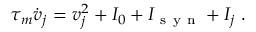Convert formula to latex. <formula><loc_0><loc_0><loc_500><loc_500>\tau _ { m } \dot { v } _ { j } = v _ { j } ^ { 2 } + I _ { 0 } + I _ { s y n } + I _ { j } \, .</formula> 